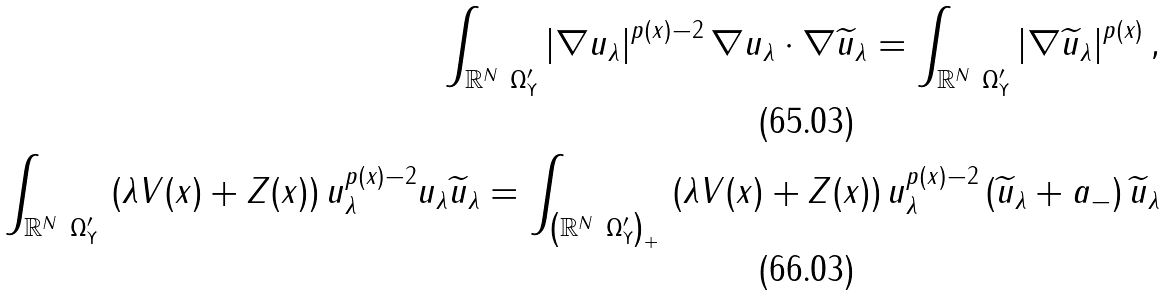<formula> <loc_0><loc_0><loc_500><loc_500>\int _ { \mathbb { R } ^ { N } \ \Omega ^ { \prime } _ { \Upsilon } } \left | \nabla u _ { \lambda } \right | ^ { p ( x ) - 2 } \nabla u _ { \lambda } \cdot \nabla \widetilde { u } _ { \lambda } = \int _ { \mathbb { R } ^ { N } \ \Omega ^ { \prime } _ { \Upsilon } } \left | \nabla \widetilde { u } _ { \lambda } \right | ^ { p ( x ) } , \\ \int _ { \mathbb { R } ^ { N } \ \Omega ^ { \prime } _ { \Upsilon } } \, \left ( \lambda V ( x ) + Z ( x ) \right ) u _ { \lambda } ^ { p ( x ) - 2 } u _ { \lambda } \widetilde { u } _ { \lambda } = \int _ { \left ( \mathbb { R } ^ { N } \ \Omega ^ { \prime } _ { \Upsilon } \right ) _ { + } } \, \left ( \lambda V ( x ) + Z ( x ) \right ) u _ { \lambda } ^ { p ( x ) - 2 } \left ( \widetilde { u } _ { \lambda } + a _ { - } \right ) \widetilde { u } _ { \lambda }</formula> 